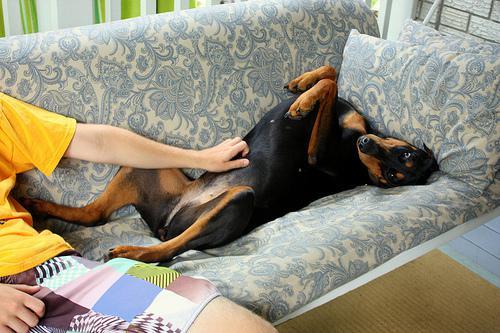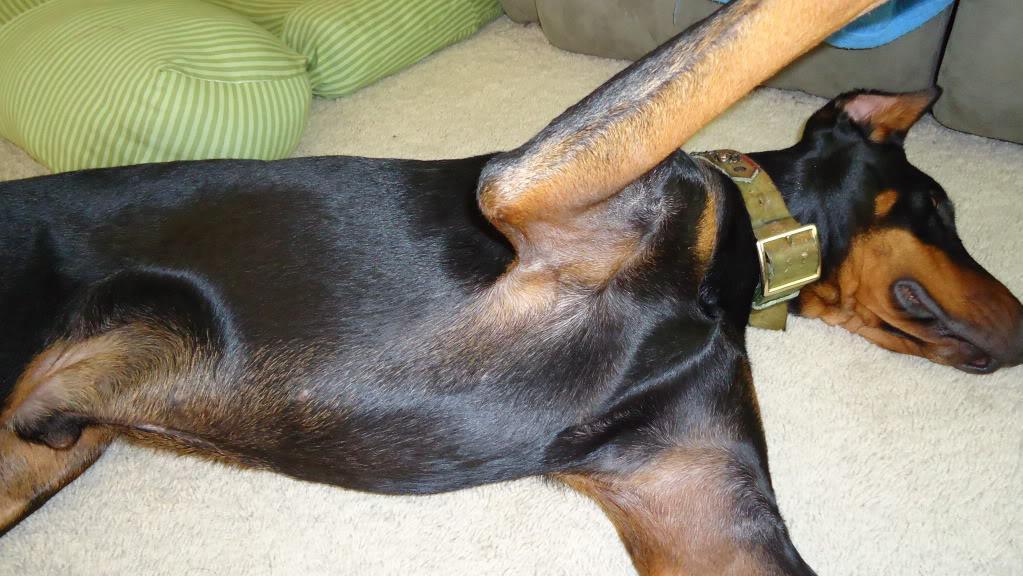The first image is the image on the left, the second image is the image on the right. Analyze the images presented: Is the assertion "A person sitting on upholstered furniture on the left of one image is touching the belly of a dog lying on its back with its front paws bent forward and hind legs extended." valid? Answer yes or no. Yes. The first image is the image on the left, the second image is the image on the right. Assess this claim about the two images: "The dog in one of the images is getting its belly rubbed.". Correct or not? Answer yes or no. Yes. 